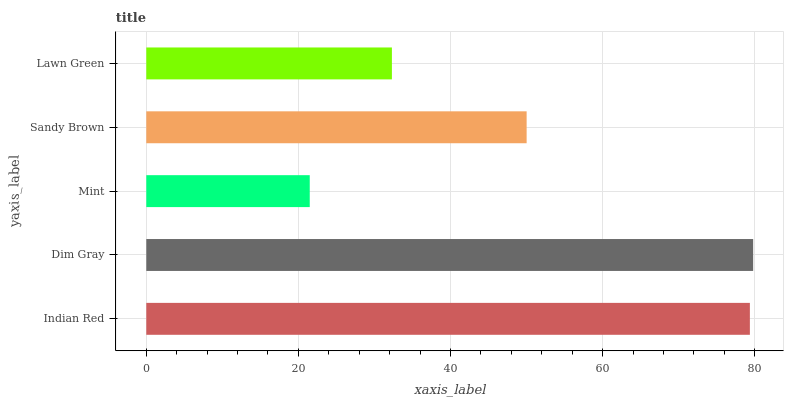Is Mint the minimum?
Answer yes or no. Yes. Is Dim Gray the maximum?
Answer yes or no. Yes. Is Dim Gray the minimum?
Answer yes or no. No. Is Mint the maximum?
Answer yes or no. No. Is Dim Gray greater than Mint?
Answer yes or no. Yes. Is Mint less than Dim Gray?
Answer yes or no. Yes. Is Mint greater than Dim Gray?
Answer yes or no. No. Is Dim Gray less than Mint?
Answer yes or no. No. Is Sandy Brown the high median?
Answer yes or no. Yes. Is Sandy Brown the low median?
Answer yes or no. Yes. Is Dim Gray the high median?
Answer yes or no. No. Is Indian Red the low median?
Answer yes or no. No. 